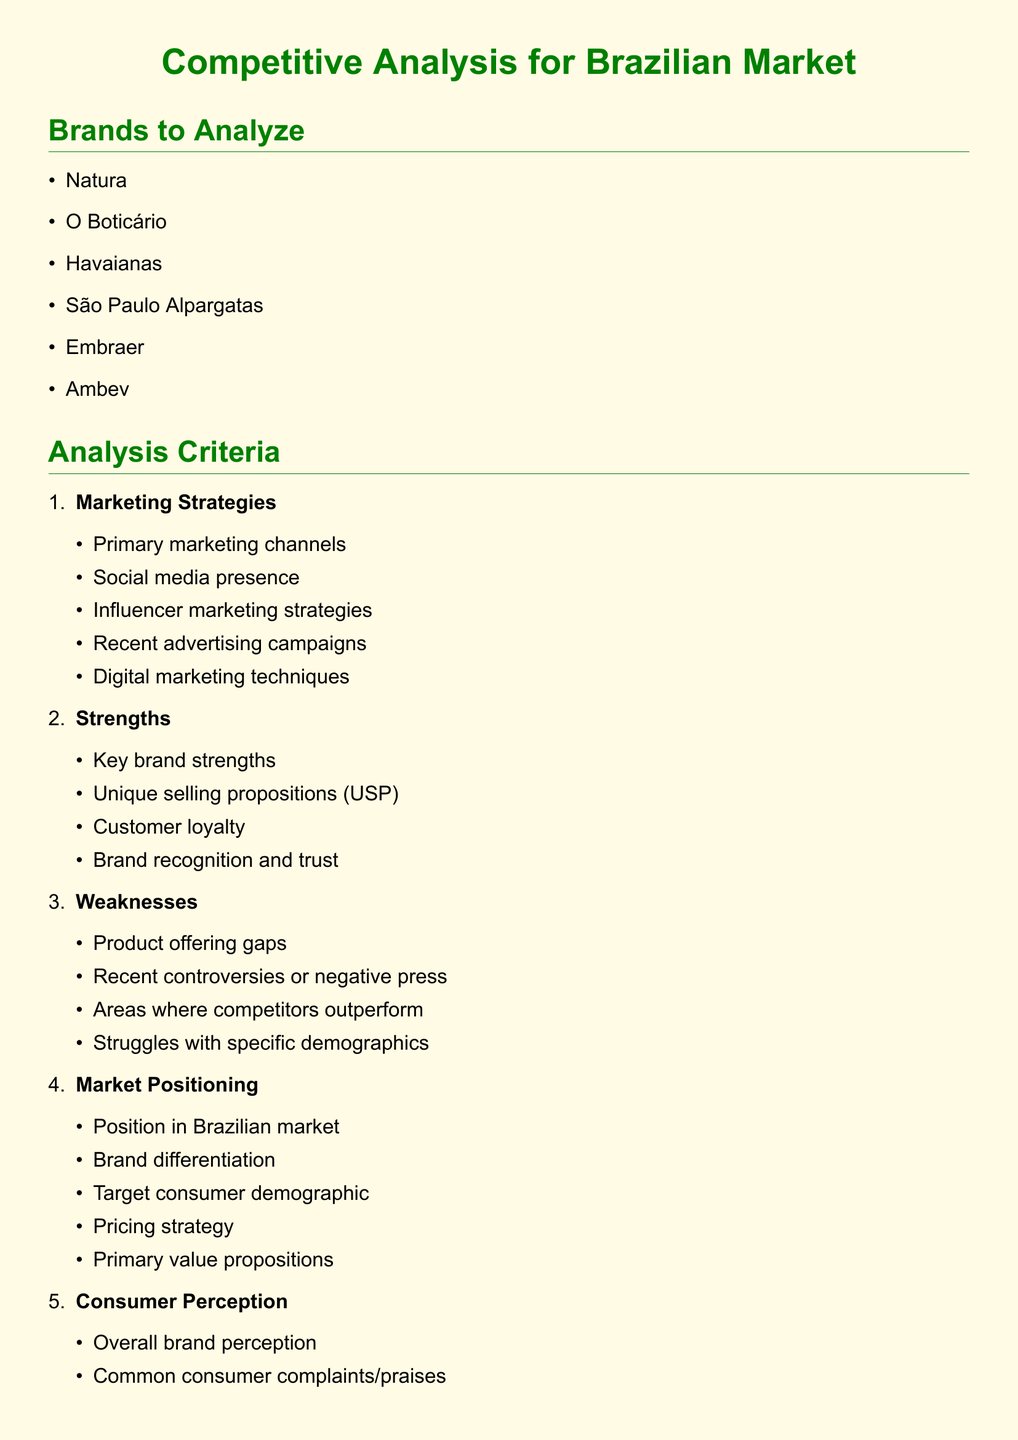what are the brands to analyze? The document lists six brands to analyze in the Brazilian market: Natura, O Boticário, Havaianas, São Paulo Alpargatas, Embraer, and Ambev.
Answer: Natura, O Boticário, Havaianas, São Paulo Alpargatas, Embraer, Ambev what is one strength mentioned for competitor brands? The document outlines various strengths for competitor brands, including unique selling propositions as a key focus.
Answer: Unique selling propositions what is one of the marketing strategies criteria? One of the marketing strategies criteria is 'social media presence.'
Answer: Social media presence how many weaknesses categories are listed? The document specifies four categories of weaknesses that brands may possess.
Answer: Four which brand is associated with e-commerce site ratings under consumer perception? The document does not assign specific brands to e-commerce ratings but discusses consumer perception in general terms.
Answer: N/A what is the main color theme used in the document? The colors defined in the document include brand green and brand yellow as the primary themes used throughout.
Answer: brand green and brand yellow what is one aspect of market positioning mentioned? The document includes 'pricing strategy' as an important aspect of evaluating market positioning for competitor brands.
Answer: Pricing strategy what is the overall focus of the document? The document focuses on performing a competitive analysis for the Brazilian market, particularly regarding brands' marketing strategies.
Answer: Competitive analysis for Brazilian market 